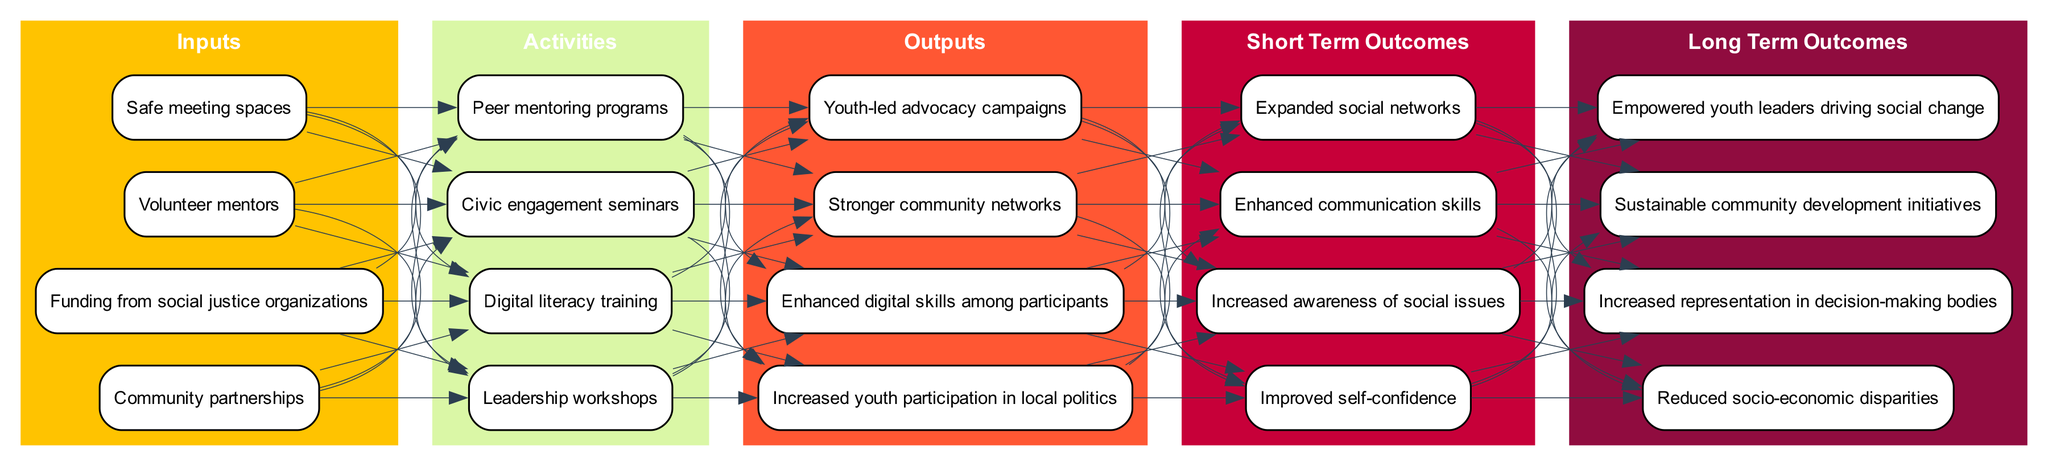What are the inputs of the program? The diagram indicates four specific inputs listed in the 'inputs' cluster: Community partnerships, Funding from social justice organizations, Volunteer mentors, and Safe meeting spaces.
Answer: Community partnerships, Funding from social justice organizations, Volunteer mentors, Safe meeting spaces How many activities are outlined in the program? By counting the nodes in the 'activities' cluster of the diagram, we can see that there are four distinct activities listed: Leadership workshops, Digital literacy training, Civic engagement seminars, and Peer mentoring programs.
Answer: 4 What is the first short-term outcome? The 'short_term_outcomes' cluster shows four outcomes, and the first one listed is Improved self-confidence. Therefore, it is the first outcome in that cluster.
Answer: Improved self-confidence Which activity is directly connected to Youth-led advocacy campaigns? The diagram shows that Youth-led advocacy campaigns is listed in the 'outputs' section. Tracing back, we find that it is connected to Civic engagement seminars, as that activity leads to this particular output.
Answer: Civic engagement seminars How many long-term outcomes does the program aim to achieve? In the 'long_term_outcomes' cluster, we can count a total of four outcomes, which are: Reduced socio-economic disparities, Increased representation in decision-making bodies, Sustainable community development initiatives, and Empowered youth leaders driving social change.
Answer: 4 Which input contributes to enhanced digital skills among participants? Looking at the connections flowing from the 'inputs' to 'outputs', Volunteer mentors lead to Enhanced digital skills among participants as part of the skills acquired in the training sessions.
Answer: Volunteer mentors What is the relationship between Leadership workshops and Empowered youth leaders driving social change? The diagram indicates that Leadership workshops lead to the short-term outcome of Improved self-confidence, which in turn contributes to the long-term outcome of Empowered youth leaders driving social change. Thus, the relationship is a sequential effect through the program’s logic model.
Answer: Leadership workshops lead to Improved self-confidence, contributing to Empowered youth leaders driving social change How many edges connect inputs to outputs in the diagram? By examining the connections in the diagram, there are three input categories that connect to outputs, and each of those connections can be traced to several outputs, leading to a total of eight edges connecting inputs to outputs.
Answer: 8 